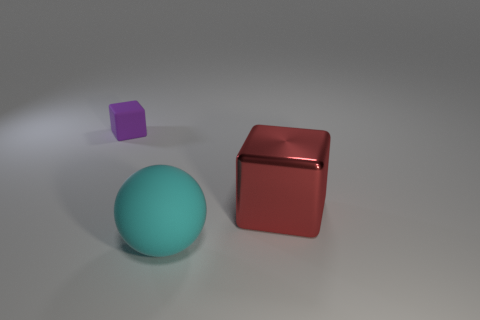What number of cyan balls have the same size as the shiny cube? There is one cyan ball that appears to have the same size as the shiny red cube in the image. 